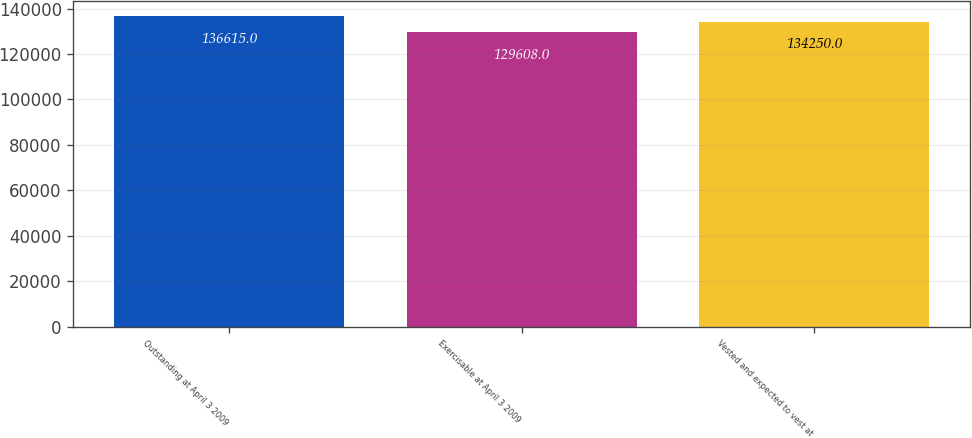Convert chart to OTSL. <chart><loc_0><loc_0><loc_500><loc_500><bar_chart><fcel>Outstanding at April 3 2009<fcel>Exercisable at April 3 2009<fcel>Vested and expected to vest at<nl><fcel>136615<fcel>129608<fcel>134250<nl></chart> 